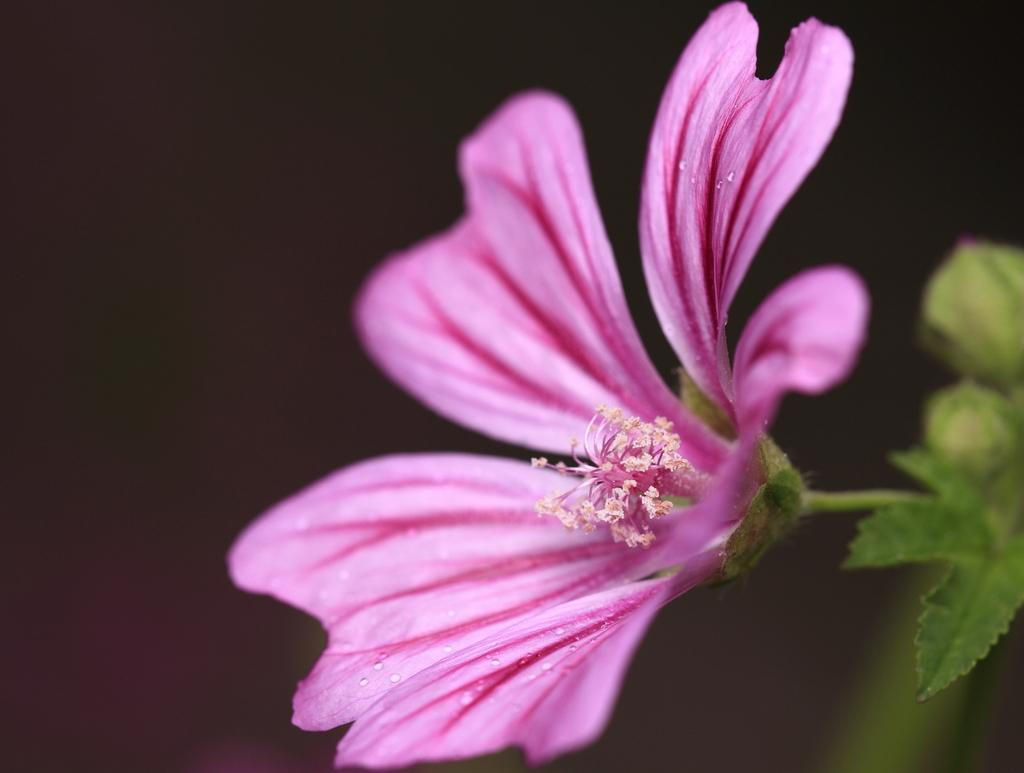What type of plant is featured in the image? The image contains a flower, a leaf, and buds, which are all parts of a plant. Can you describe the plant's growth stage based on the image? The presence of buds suggests that the plant is in the process of blooming. What is the color of the background in the image? The background of the image is dark. What type of string is being used to tie the class together in the image? There is no mention of a class or string in the image; it features a flower, a leaf, and buds against a dark background. 